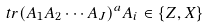Convert formula to latex. <formula><loc_0><loc_0><loc_500><loc_500>\ t r ( A _ { 1 } A _ { 2 } \cdots A _ { J } ) ^ { a } A _ { i } \in \{ Z , X \}</formula> 